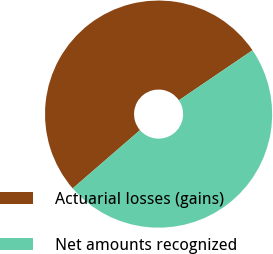Convert chart. <chart><loc_0><loc_0><loc_500><loc_500><pie_chart><fcel>Actuarial losses (gains)<fcel>Net amounts recognized<nl><fcel>51.85%<fcel>48.15%<nl></chart> 